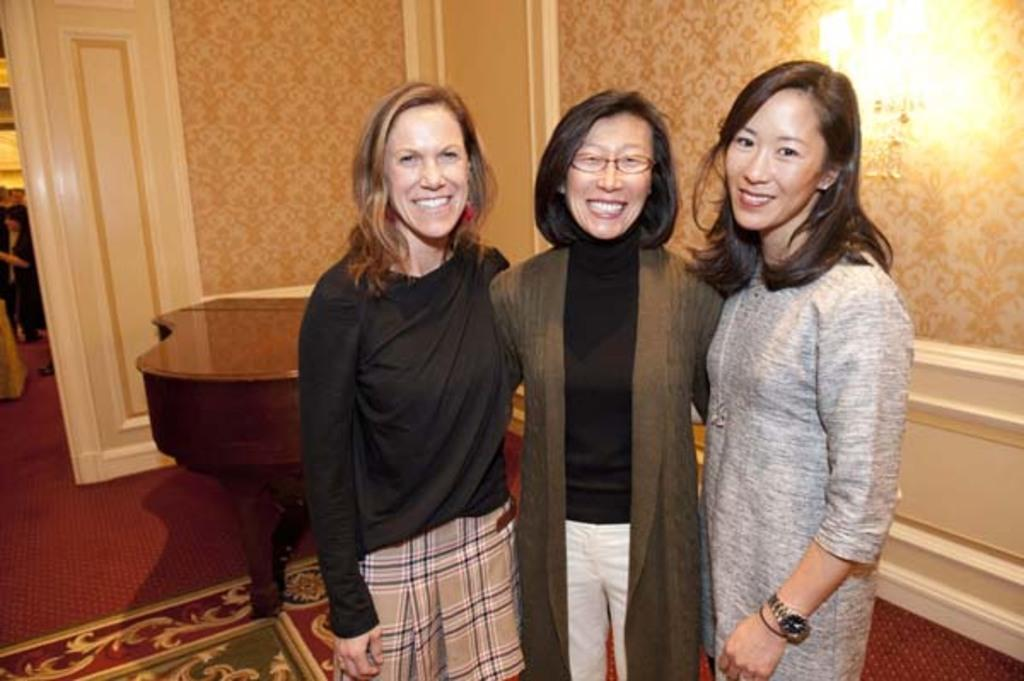How many women are in the front of the image? There are three women standing in the front of the image. What expression do the women have? The women are smiling. What type of floor is visible in the image? There is a floor with a carpet in the image. What can be seen in the background of the image? There are walls, people, a table, and a light on the wall in the background of the image. What type of finger can be seen touching the light on the wall in the image? There is no finger touching the light on the wall in the image. What is the limit of the women's smiles in the image? The women's smiles do not have a limit; they are simply smiling. 